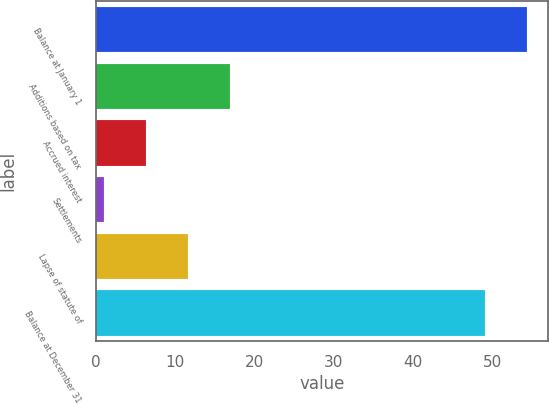<chart> <loc_0><loc_0><loc_500><loc_500><bar_chart><fcel>Balance at January 1<fcel>Additions based on tax<fcel>Accrued interest<fcel>Settlements<fcel>Lapse of statute of<fcel>Balance at December 31<nl><fcel>54.3<fcel>16.9<fcel>6.3<fcel>1<fcel>11.6<fcel>49<nl></chart> 